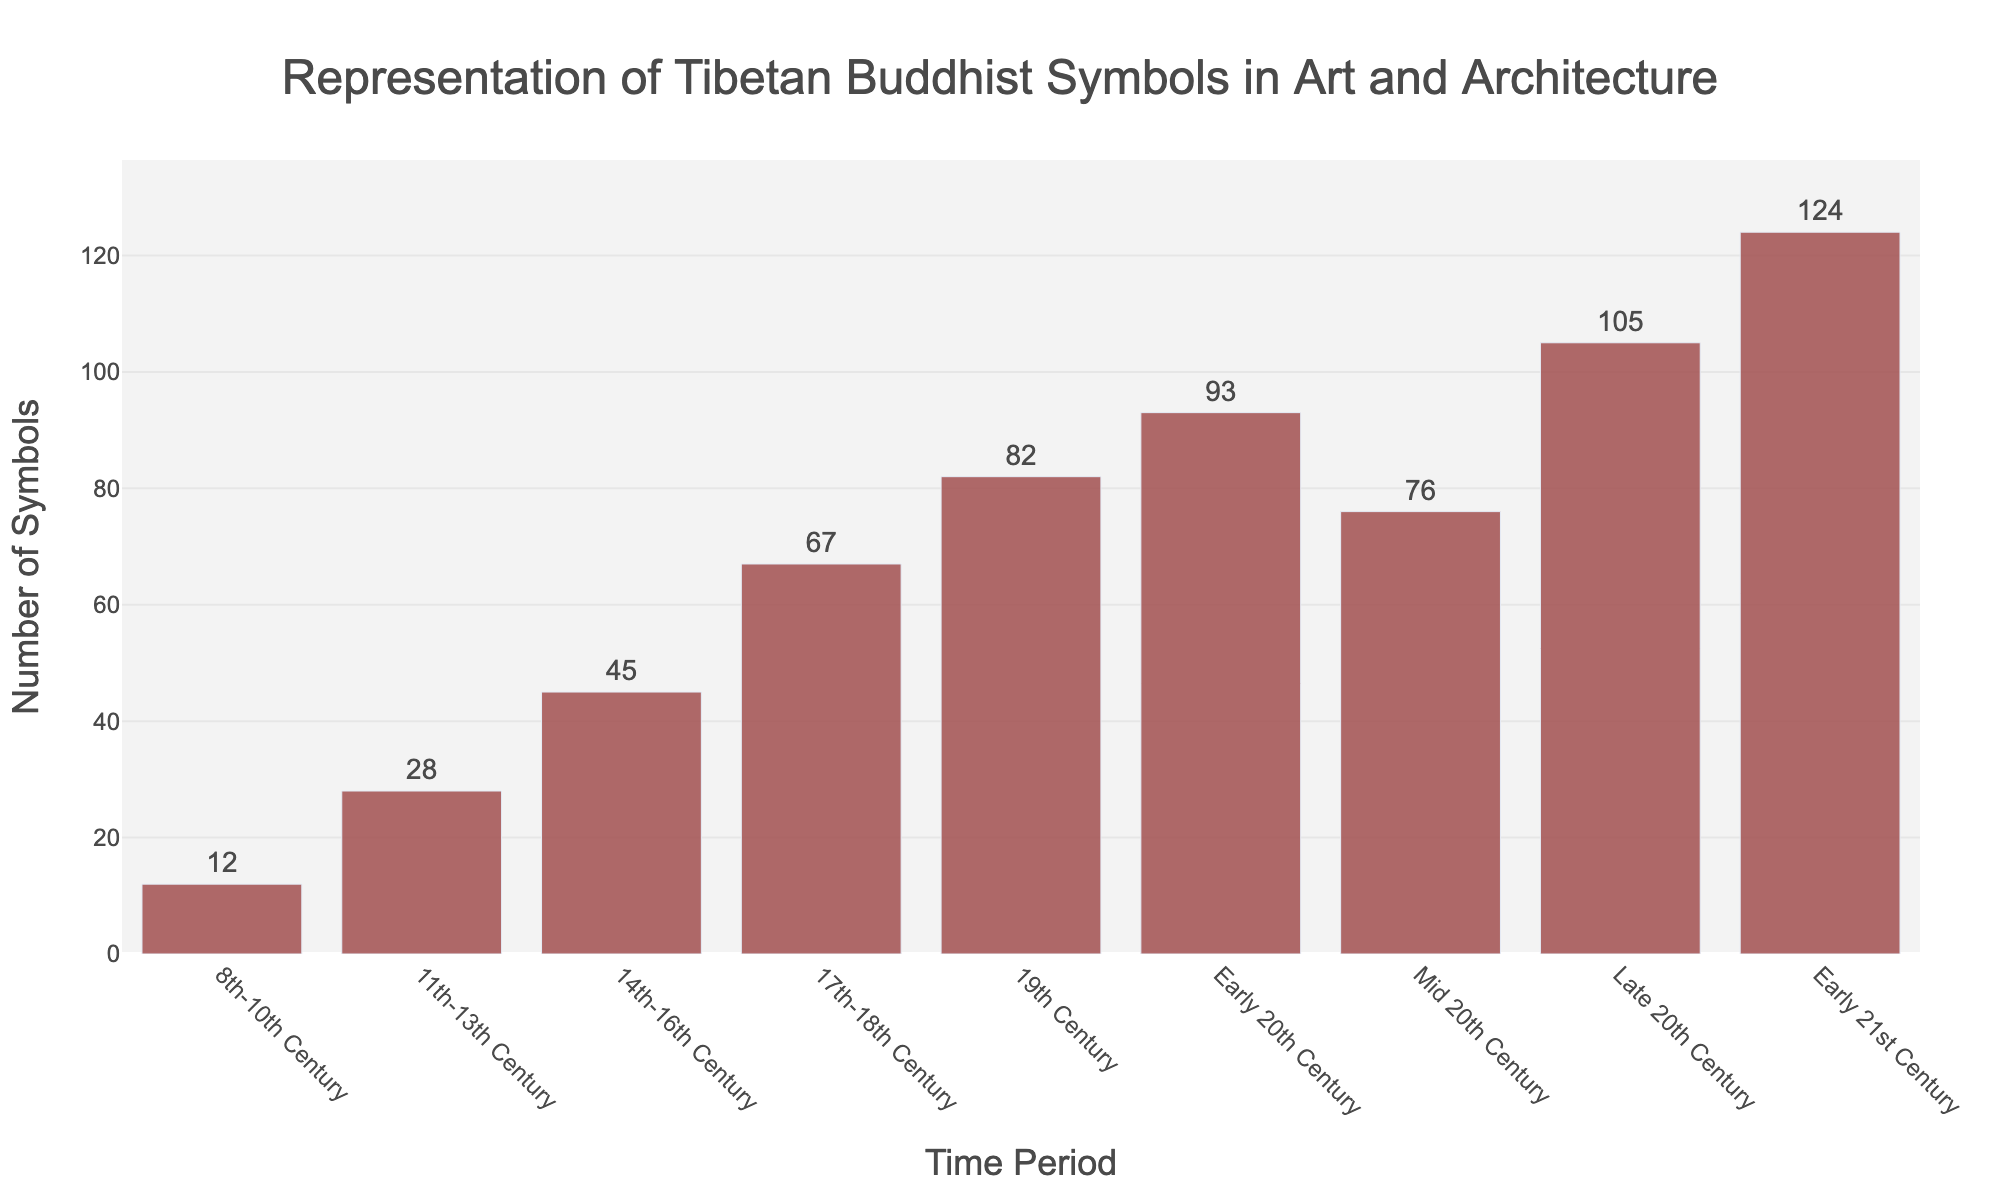What is the total number of Tibetan Buddhist symbols represented in art and architecture from the 8th to the 18th century? Sum the numbers of symbols from 8th-10th Century, 11th-13th Century, 14th-16th Century, and 17th-18th Century: 12 + 28 + 45 + 67 = 152
Answer: 152 Which time period has the highest representation of Tibetan Buddhist symbols? Identify the time period with the maximum number of symbols. Based on the bar heights, the "Early 21st Century" has the highest number of 124 symbols.
Answer: Early 21st Century How many more symbols were represented in the Late 20th Century compared to the Early 20th Century? Subtract the number of symbols in the Early 20th Century from the number in the Late 20th Century: 105 - 93 = 12
Answer: 12 Compare the number of symbols in the 19th Century to the Mid 20th Century. Which time period had fewer symbols and by how much? The 19th Century had 82 symbols and the Mid 20th Century had 76 symbols. The Mid 20th Century had 6 fewer symbols than the 19th Century: 82 - 76 = 6
Answer: Mid 20th Century, by 6 Is the number of symbols in the Early 21st Century greater than the combined total of the 8th-10th Century and the 11th-13th Century? Sum the number of symbols in the 8th-10th Century and the 11th-13th Century: 12 + 28 = 40. Compare this sum to the number in the Early 21st Century, which is 124. Since 124 > 40, the Early 21st Century has more symbols.
Answer: Yes What is the average number of symbols represented from the 14th-16th Century to the Late 20th Century? Calculate the sum of symbols for the periods from the 14th-16th Century to the Late 20th Century: 45 + 67 + 82 + 93 + 76 + 105 = 468. Then divide by the number of periods (6): 468 / 6 = 78
Answer: 78 How does the representation in the Mid 20th Century compare to the average representation of all the other time periods combined? Calculate the sum of symbols for all periods except the Mid 20th Century: 12 + 28 + 45 + 67 + 82 + 93 + 105 + 124 = 556. The average for these periods is 556 / 8 = 69.5. Compare this to the Mid 20th Century representation, which is 76. Since 76 > 69.5, the Mid 20th Century has more symbols than the average.
Answer: More, by 6.5 symbols During which century did the representation of symbols increase the most compared to the previous century? Compare each century's increase: 
11th-13th Century (28 - 12 = 16), 
14th-16th Century (45 - 28 = 17), 
17th-18th Century (67 - 45 = 22), 
19th Century (82 - 67 = 15). 
The largest increase is in the 17th-18th Century with a 22-symbol increase.
Answer: 17th-18th Century What can be inferred about the change in representation of symbols from the Early 20th Century to the Late 20th Century? Compare the number of symbols: Early 20th Century (93) to Late 20th Century (105). The increase suggests a growing interest or cultural resurgence in depicting Tibetan Buddhist symbols as time progressed towards the late 20th Century.
Answer: Increase What is the trend observed in the representation of symbols from the 8th century to the Early 21st century based on the chart? The trend shows a general increase in the number of symbols over time, with occasional fluctuations, culminating in the highest representation in the Early 21st Century.
Answer: Increasing trend 